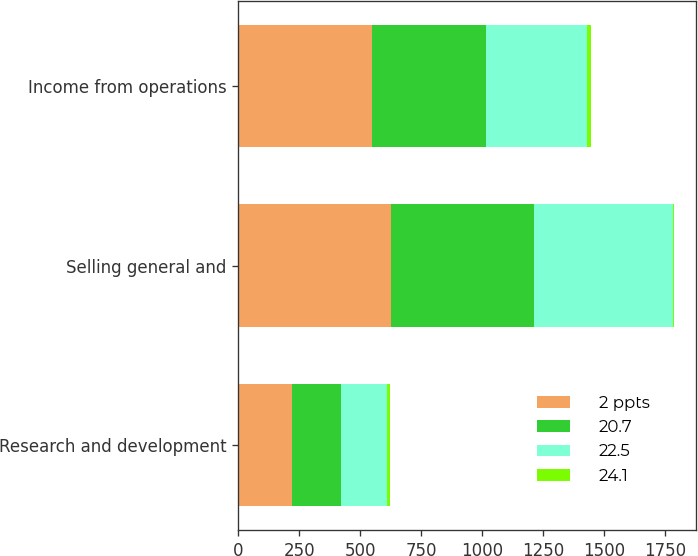<chart> <loc_0><loc_0><loc_500><loc_500><stacked_bar_chart><ecel><fcel>Research and development<fcel>Selling general and<fcel>Income from operations<nl><fcel>2 ppts<fcel>219<fcel>625<fcel>547<nl><fcel>20.7<fcel>201<fcel>585<fcel>468<nl><fcel>22.5<fcel>191<fcel>569<fcel>412<nl><fcel>24.1<fcel>9<fcel>7<fcel>17<nl></chart> 